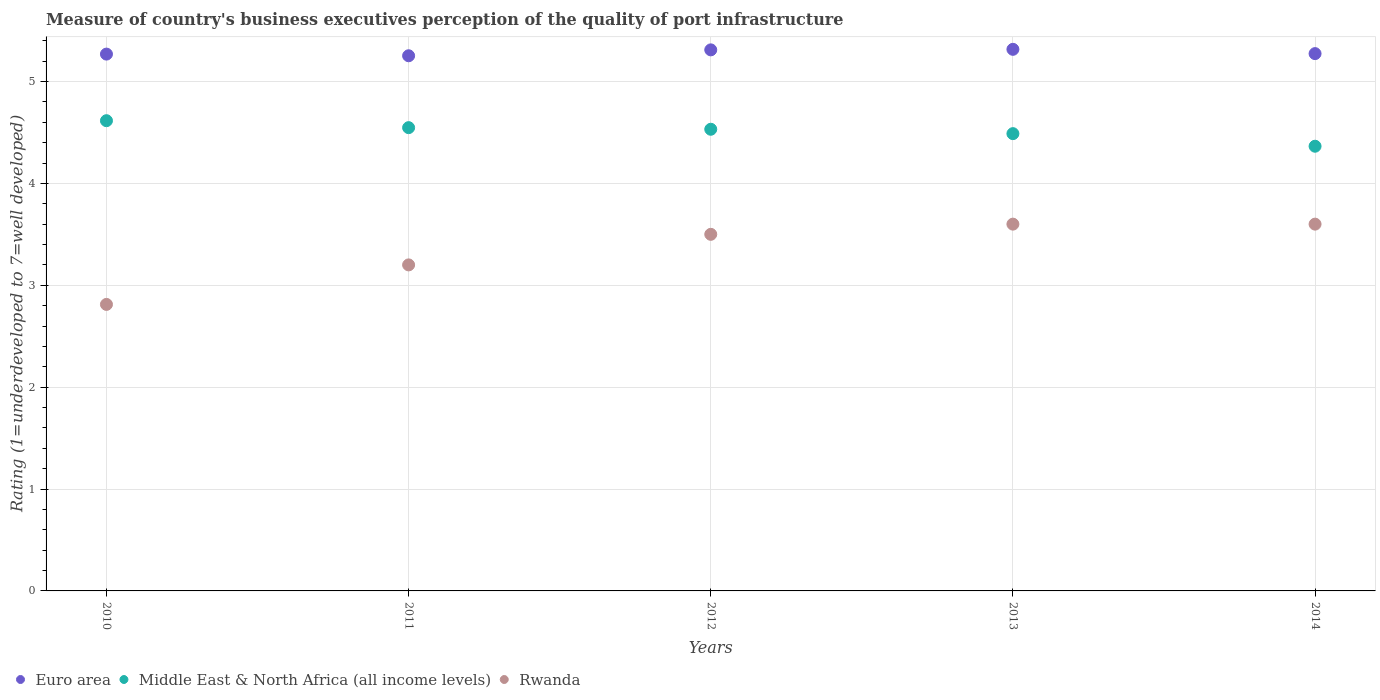How many different coloured dotlines are there?
Your response must be concise. 3. Across all years, what is the minimum ratings of the quality of port infrastructure in Rwanda?
Make the answer very short. 2.81. In which year was the ratings of the quality of port infrastructure in Rwanda minimum?
Your answer should be compact. 2010. What is the total ratings of the quality of port infrastructure in Middle East & North Africa (all income levels) in the graph?
Offer a terse response. 22.55. What is the difference between the ratings of the quality of port infrastructure in Middle East & North Africa (all income levels) in 2011 and that in 2014?
Offer a terse response. 0.18. What is the difference between the ratings of the quality of port infrastructure in Middle East & North Africa (all income levels) in 2010 and the ratings of the quality of port infrastructure in Euro area in 2012?
Ensure brevity in your answer.  -0.7. What is the average ratings of the quality of port infrastructure in Rwanda per year?
Ensure brevity in your answer.  3.34. In the year 2010, what is the difference between the ratings of the quality of port infrastructure in Middle East & North Africa (all income levels) and ratings of the quality of port infrastructure in Rwanda?
Offer a terse response. 1.8. In how many years, is the ratings of the quality of port infrastructure in Euro area greater than 0.4?
Offer a very short reply. 5. Is the ratings of the quality of port infrastructure in Rwanda in 2010 less than that in 2013?
Keep it short and to the point. Yes. What is the difference between the highest and the second highest ratings of the quality of port infrastructure in Middle East & North Africa (all income levels)?
Offer a terse response. 0.07. What is the difference between the highest and the lowest ratings of the quality of port infrastructure in Rwanda?
Provide a short and direct response. 0.79. Is the sum of the ratings of the quality of port infrastructure in Middle East & North Africa (all income levels) in 2010 and 2014 greater than the maximum ratings of the quality of port infrastructure in Rwanda across all years?
Offer a very short reply. Yes. Is it the case that in every year, the sum of the ratings of the quality of port infrastructure in Rwanda and ratings of the quality of port infrastructure in Euro area  is greater than the ratings of the quality of port infrastructure in Middle East & North Africa (all income levels)?
Your answer should be very brief. Yes. Is the ratings of the quality of port infrastructure in Rwanda strictly greater than the ratings of the quality of port infrastructure in Euro area over the years?
Your answer should be very brief. No. Is the ratings of the quality of port infrastructure in Euro area strictly less than the ratings of the quality of port infrastructure in Middle East & North Africa (all income levels) over the years?
Make the answer very short. No. Are the values on the major ticks of Y-axis written in scientific E-notation?
Offer a very short reply. No. Does the graph contain any zero values?
Offer a terse response. No. Does the graph contain grids?
Provide a short and direct response. Yes. How many legend labels are there?
Your answer should be compact. 3. What is the title of the graph?
Give a very brief answer. Measure of country's business executives perception of the quality of port infrastructure. What is the label or title of the X-axis?
Give a very brief answer. Years. What is the label or title of the Y-axis?
Your response must be concise. Rating (1=underdeveloped to 7=well developed). What is the Rating (1=underdeveloped to 7=well developed) of Euro area in 2010?
Offer a terse response. 5.27. What is the Rating (1=underdeveloped to 7=well developed) of Middle East & North Africa (all income levels) in 2010?
Make the answer very short. 4.62. What is the Rating (1=underdeveloped to 7=well developed) of Rwanda in 2010?
Offer a terse response. 2.81. What is the Rating (1=underdeveloped to 7=well developed) of Euro area in 2011?
Your answer should be very brief. 5.25. What is the Rating (1=underdeveloped to 7=well developed) of Middle East & North Africa (all income levels) in 2011?
Provide a short and direct response. 4.55. What is the Rating (1=underdeveloped to 7=well developed) of Euro area in 2012?
Offer a very short reply. 5.31. What is the Rating (1=underdeveloped to 7=well developed) in Middle East & North Africa (all income levels) in 2012?
Your response must be concise. 4.53. What is the Rating (1=underdeveloped to 7=well developed) of Euro area in 2013?
Ensure brevity in your answer.  5.32. What is the Rating (1=underdeveloped to 7=well developed) in Middle East & North Africa (all income levels) in 2013?
Ensure brevity in your answer.  4.49. What is the Rating (1=underdeveloped to 7=well developed) of Euro area in 2014?
Ensure brevity in your answer.  5.27. What is the Rating (1=underdeveloped to 7=well developed) of Middle East & North Africa (all income levels) in 2014?
Offer a terse response. 4.36. What is the Rating (1=underdeveloped to 7=well developed) of Rwanda in 2014?
Make the answer very short. 3.6. Across all years, what is the maximum Rating (1=underdeveloped to 7=well developed) of Euro area?
Give a very brief answer. 5.32. Across all years, what is the maximum Rating (1=underdeveloped to 7=well developed) in Middle East & North Africa (all income levels)?
Keep it short and to the point. 4.62. Across all years, what is the minimum Rating (1=underdeveloped to 7=well developed) of Euro area?
Ensure brevity in your answer.  5.25. Across all years, what is the minimum Rating (1=underdeveloped to 7=well developed) of Middle East & North Africa (all income levels)?
Provide a short and direct response. 4.36. Across all years, what is the minimum Rating (1=underdeveloped to 7=well developed) of Rwanda?
Keep it short and to the point. 2.81. What is the total Rating (1=underdeveloped to 7=well developed) of Euro area in the graph?
Offer a very short reply. 26.42. What is the total Rating (1=underdeveloped to 7=well developed) of Middle East & North Africa (all income levels) in the graph?
Make the answer very short. 22.55. What is the total Rating (1=underdeveloped to 7=well developed) in Rwanda in the graph?
Provide a short and direct response. 16.71. What is the difference between the Rating (1=underdeveloped to 7=well developed) in Euro area in 2010 and that in 2011?
Keep it short and to the point. 0.02. What is the difference between the Rating (1=underdeveloped to 7=well developed) in Middle East & North Africa (all income levels) in 2010 and that in 2011?
Provide a short and direct response. 0.07. What is the difference between the Rating (1=underdeveloped to 7=well developed) in Rwanda in 2010 and that in 2011?
Your answer should be very brief. -0.39. What is the difference between the Rating (1=underdeveloped to 7=well developed) of Euro area in 2010 and that in 2012?
Provide a short and direct response. -0.04. What is the difference between the Rating (1=underdeveloped to 7=well developed) in Middle East & North Africa (all income levels) in 2010 and that in 2012?
Your answer should be compact. 0.08. What is the difference between the Rating (1=underdeveloped to 7=well developed) of Rwanda in 2010 and that in 2012?
Provide a short and direct response. -0.69. What is the difference between the Rating (1=underdeveloped to 7=well developed) in Euro area in 2010 and that in 2013?
Give a very brief answer. -0.05. What is the difference between the Rating (1=underdeveloped to 7=well developed) of Middle East & North Africa (all income levels) in 2010 and that in 2013?
Offer a terse response. 0.13. What is the difference between the Rating (1=underdeveloped to 7=well developed) of Rwanda in 2010 and that in 2013?
Your response must be concise. -0.79. What is the difference between the Rating (1=underdeveloped to 7=well developed) in Euro area in 2010 and that in 2014?
Your response must be concise. -0. What is the difference between the Rating (1=underdeveloped to 7=well developed) of Middle East & North Africa (all income levels) in 2010 and that in 2014?
Provide a short and direct response. 0.25. What is the difference between the Rating (1=underdeveloped to 7=well developed) in Rwanda in 2010 and that in 2014?
Your answer should be very brief. -0.79. What is the difference between the Rating (1=underdeveloped to 7=well developed) of Euro area in 2011 and that in 2012?
Provide a succinct answer. -0.06. What is the difference between the Rating (1=underdeveloped to 7=well developed) in Middle East & North Africa (all income levels) in 2011 and that in 2012?
Make the answer very short. 0.02. What is the difference between the Rating (1=underdeveloped to 7=well developed) of Euro area in 2011 and that in 2013?
Make the answer very short. -0.06. What is the difference between the Rating (1=underdeveloped to 7=well developed) in Middle East & North Africa (all income levels) in 2011 and that in 2013?
Provide a short and direct response. 0.06. What is the difference between the Rating (1=underdeveloped to 7=well developed) in Rwanda in 2011 and that in 2013?
Your answer should be compact. -0.4. What is the difference between the Rating (1=underdeveloped to 7=well developed) of Euro area in 2011 and that in 2014?
Keep it short and to the point. -0.02. What is the difference between the Rating (1=underdeveloped to 7=well developed) in Middle East & North Africa (all income levels) in 2011 and that in 2014?
Offer a terse response. 0.18. What is the difference between the Rating (1=underdeveloped to 7=well developed) in Euro area in 2012 and that in 2013?
Keep it short and to the point. -0.01. What is the difference between the Rating (1=underdeveloped to 7=well developed) of Middle East & North Africa (all income levels) in 2012 and that in 2013?
Make the answer very short. 0.04. What is the difference between the Rating (1=underdeveloped to 7=well developed) of Rwanda in 2012 and that in 2013?
Give a very brief answer. -0.1. What is the difference between the Rating (1=underdeveloped to 7=well developed) in Euro area in 2012 and that in 2014?
Offer a terse response. 0.04. What is the difference between the Rating (1=underdeveloped to 7=well developed) in Middle East & North Africa (all income levels) in 2012 and that in 2014?
Provide a short and direct response. 0.17. What is the difference between the Rating (1=underdeveloped to 7=well developed) in Euro area in 2013 and that in 2014?
Offer a very short reply. 0.04. What is the difference between the Rating (1=underdeveloped to 7=well developed) of Middle East & North Africa (all income levels) in 2013 and that in 2014?
Provide a short and direct response. 0.12. What is the difference between the Rating (1=underdeveloped to 7=well developed) in Euro area in 2010 and the Rating (1=underdeveloped to 7=well developed) in Middle East & North Africa (all income levels) in 2011?
Ensure brevity in your answer.  0.72. What is the difference between the Rating (1=underdeveloped to 7=well developed) of Euro area in 2010 and the Rating (1=underdeveloped to 7=well developed) of Rwanda in 2011?
Keep it short and to the point. 2.07. What is the difference between the Rating (1=underdeveloped to 7=well developed) in Middle East & North Africa (all income levels) in 2010 and the Rating (1=underdeveloped to 7=well developed) in Rwanda in 2011?
Provide a short and direct response. 1.42. What is the difference between the Rating (1=underdeveloped to 7=well developed) in Euro area in 2010 and the Rating (1=underdeveloped to 7=well developed) in Middle East & North Africa (all income levels) in 2012?
Provide a succinct answer. 0.74. What is the difference between the Rating (1=underdeveloped to 7=well developed) of Euro area in 2010 and the Rating (1=underdeveloped to 7=well developed) of Rwanda in 2012?
Your answer should be very brief. 1.77. What is the difference between the Rating (1=underdeveloped to 7=well developed) of Middle East & North Africa (all income levels) in 2010 and the Rating (1=underdeveloped to 7=well developed) of Rwanda in 2012?
Offer a terse response. 1.12. What is the difference between the Rating (1=underdeveloped to 7=well developed) in Euro area in 2010 and the Rating (1=underdeveloped to 7=well developed) in Middle East & North Africa (all income levels) in 2013?
Make the answer very short. 0.78. What is the difference between the Rating (1=underdeveloped to 7=well developed) of Euro area in 2010 and the Rating (1=underdeveloped to 7=well developed) of Rwanda in 2013?
Offer a terse response. 1.67. What is the difference between the Rating (1=underdeveloped to 7=well developed) in Middle East & North Africa (all income levels) in 2010 and the Rating (1=underdeveloped to 7=well developed) in Rwanda in 2013?
Give a very brief answer. 1.02. What is the difference between the Rating (1=underdeveloped to 7=well developed) in Euro area in 2010 and the Rating (1=underdeveloped to 7=well developed) in Middle East & North Africa (all income levels) in 2014?
Provide a short and direct response. 0.9. What is the difference between the Rating (1=underdeveloped to 7=well developed) of Euro area in 2010 and the Rating (1=underdeveloped to 7=well developed) of Rwanda in 2014?
Give a very brief answer. 1.67. What is the difference between the Rating (1=underdeveloped to 7=well developed) of Middle East & North Africa (all income levels) in 2010 and the Rating (1=underdeveloped to 7=well developed) of Rwanda in 2014?
Provide a short and direct response. 1.02. What is the difference between the Rating (1=underdeveloped to 7=well developed) of Euro area in 2011 and the Rating (1=underdeveloped to 7=well developed) of Middle East & North Africa (all income levels) in 2012?
Offer a very short reply. 0.72. What is the difference between the Rating (1=underdeveloped to 7=well developed) of Euro area in 2011 and the Rating (1=underdeveloped to 7=well developed) of Rwanda in 2012?
Offer a very short reply. 1.75. What is the difference between the Rating (1=underdeveloped to 7=well developed) in Middle East & North Africa (all income levels) in 2011 and the Rating (1=underdeveloped to 7=well developed) in Rwanda in 2012?
Give a very brief answer. 1.05. What is the difference between the Rating (1=underdeveloped to 7=well developed) in Euro area in 2011 and the Rating (1=underdeveloped to 7=well developed) in Middle East & North Africa (all income levels) in 2013?
Ensure brevity in your answer.  0.76. What is the difference between the Rating (1=underdeveloped to 7=well developed) of Euro area in 2011 and the Rating (1=underdeveloped to 7=well developed) of Rwanda in 2013?
Your answer should be very brief. 1.65. What is the difference between the Rating (1=underdeveloped to 7=well developed) in Middle East & North Africa (all income levels) in 2011 and the Rating (1=underdeveloped to 7=well developed) in Rwanda in 2013?
Offer a terse response. 0.95. What is the difference between the Rating (1=underdeveloped to 7=well developed) in Euro area in 2011 and the Rating (1=underdeveloped to 7=well developed) in Middle East & North Africa (all income levels) in 2014?
Keep it short and to the point. 0.89. What is the difference between the Rating (1=underdeveloped to 7=well developed) of Euro area in 2011 and the Rating (1=underdeveloped to 7=well developed) of Rwanda in 2014?
Offer a very short reply. 1.65. What is the difference between the Rating (1=underdeveloped to 7=well developed) of Middle East & North Africa (all income levels) in 2011 and the Rating (1=underdeveloped to 7=well developed) of Rwanda in 2014?
Provide a succinct answer. 0.95. What is the difference between the Rating (1=underdeveloped to 7=well developed) in Euro area in 2012 and the Rating (1=underdeveloped to 7=well developed) in Middle East & North Africa (all income levels) in 2013?
Provide a succinct answer. 0.82. What is the difference between the Rating (1=underdeveloped to 7=well developed) of Euro area in 2012 and the Rating (1=underdeveloped to 7=well developed) of Rwanda in 2013?
Give a very brief answer. 1.71. What is the difference between the Rating (1=underdeveloped to 7=well developed) of Middle East & North Africa (all income levels) in 2012 and the Rating (1=underdeveloped to 7=well developed) of Rwanda in 2013?
Provide a short and direct response. 0.93. What is the difference between the Rating (1=underdeveloped to 7=well developed) of Euro area in 2012 and the Rating (1=underdeveloped to 7=well developed) of Middle East & North Africa (all income levels) in 2014?
Keep it short and to the point. 0.95. What is the difference between the Rating (1=underdeveloped to 7=well developed) of Euro area in 2012 and the Rating (1=underdeveloped to 7=well developed) of Rwanda in 2014?
Offer a terse response. 1.71. What is the difference between the Rating (1=underdeveloped to 7=well developed) of Middle East & North Africa (all income levels) in 2012 and the Rating (1=underdeveloped to 7=well developed) of Rwanda in 2014?
Provide a short and direct response. 0.93. What is the difference between the Rating (1=underdeveloped to 7=well developed) of Euro area in 2013 and the Rating (1=underdeveloped to 7=well developed) of Middle East & North Africa (all income levels) in 2014?
Provide a succinct answer. 0.95. What is the difference between the Rating (1=underdeveloped to 7=well developed) in Euro area in 2013 and the Rating (1=underdeveloped to 7=well developed) in Rwanda in 2014?
Ensure brevity in your answer.  1.72. What is the difference between the Rating (1=underdeveloped to 7=well developed) in Middle East & North Africa (all income levels) in 2013 and the Rating (1=underdeveloped to 7=well developed) in Rwanda in 2014?
Keep it short and to the point. 0.89. What is the average Rating (1=underdeveloped to 7=well developed) of Euro area per year?
Offer a terse response. 5.28. What is the average Rating (1=underdeveloped to 7=well developed) of Middle East & North Africa (all income levels) per year?
Your answer should be compact. 4.51. What is the average Rating (1=underdeveloped to 7=well developed) of Rwanda per year?
Ensure brevity in your answer.  3.34. In the year 2010, what is the difference between the Rating (1=underdeveloped to 7=well developed) of Euro area and Rating (1=underdeveloped to 7=well developed) of Middle East & North Africa (all income levels)?
Provide a succinct answer. 0.65. In the year 2010, what is the difference between the Rating (1=underdeveloped to 7=well developed) of Euro area and Rating (1=underdeveloped to 7=well developed) of Rwanda?
Offer a very short reply. 2.46. In the year 2010, what is the difference between the Rating (1=underdeveloped to 7=well developed) of Middle East & North Africa (all income levels) and Rating (1=underdeveloped to 7=well developed) of Rwanda?
Give a very brief answer. 1.8. In the year 2011, what is the difference between the Rating (1=underdeveloped to 7=well developed) of Euro area and Rating (1=underdeveloped to 7=well developed) of Middle East & North Africa (all income levels)?
Provide a short and direct response. 0.71. In the year 2011, what is the difference between the Rating (1=underdeveloped to 7=well developed) in Euro area and Rating (1=underdeveloped to 7=well developed) in Rwanda?
Ensure brevity in your answer.  2.05. In the year 2011, what is the difference between the Rating (1=underdeveloped to 7=well developed) in Middle East & North Africa (all income levels) and Rating (1=underdeveloped to 7=well developed) in Rwanda?
Make the answer very short. 1.35. In the year 2012, what is the difference between the Rating (1=underdeveloped to 7=well developed) of Euro area and Rating (1=underdeveloped to 7=well developed) of Middle East & North Africa (all income levels)?
Your answer should be very brief. 0.78. In the year 2012, what is the difference between the Rating (1=underdeveloped to 7=well developed) in Euro area and Rating (1=underdeveloped to 7=well developed) in Rwanda?
Your response must be concise. 1.81. In the year 2012, what is the difference between the Rating (1=underdeveloped to 7=well developed) in Middle East & North Africa (all income levels) and Rating (1=underdeveloped to 7=well developed) in Rwanda?
Make the answer very short. 1.03. In the year 2013, what is the difference between the Rating (1=underdeveloped to 7=well developed) of Euro area and Rating (1=underdeveloped to 7=well developed) of Middle East & North Africa (all income levels)?
Provide a short and direct response. 0.83. In the year 2013, what is the difference between the Rating (1=underdeveloped to 7=well developed) in Euro area and Rating (1=underdeveloped to 7=well developed) in Rwanda?
Give a very brief answer. 1.72. In the year 2013, what is the difference between the Rating (1=underdeveloped to 7=well developed) of Middle East & North Africa (all income levels) and Rating (1=underdeveloped to 7=well developed) of Rwanda?
Your response must be concise. 0.89. In the year 2014, what is the difference between the Rating (1=underdeveloped to 7=well developed) of Euro area and Rating (1=underdeveloped to 7=well developed) of Middle East & North Africa (all income levels)?
Offer a terse response. 0.91. In the year 2014, what is the difference between the Rating (1=underdeveloped to 7=well developed) in Euro area and Rating (1=underdeveloped to 7=well developed) in Rwanda?
Make the answer very short. 1.67. In the year 2014, what is the difference between the Rating (1=underdeveloped to 7=well developed) of Middle East & North Africa (all income levels) and Rating (1=underdeveloped to 7=well developed) of Rwanda?
Make the answer very short. 0.76. What is the ratio of the Rating (1=underdeveloped to 7=well developed) of Rwanda in 2010 to that in 2011?
Make the answer very short. 0.88. What is the ratio of the Rating (1=underdeveloped to 7=well developed) in Middle East & North Africa (all income levels) in 2010 to that in 2012?
Make the answer very short. 1.02. What is the ratio of the Rating (1=underdeveloped to 7=well developed) in Rwanda in 2010 to that in 2012?
Make the answer very short. 0.8. What is the ratio of the Rating (1=underdeveloped to 7=well developed) in Euro area in 2010 to that in 2013?
Make the answer very short. 0.99. What is the ratio of the Rating (1=underdeveloped to 7=well developed) in Middle East & North Africa (all income levels) in 2010 to that in 2013?
Make the answer very short. 1.03. What is the ratio of the Rating (1=underdeveloped to 7=well developed) of Rwanda in 2010 to that in 2013?
Your answer should be very brief. 0.78. What is the ratio of the Rating (1=underdeveloped to 7=well developed) in Middle East & North Africa (all income levels) in 2010 to that in 2014?
Ensure brevity in your answer.  1.06. What is the ratio of the Rating (1=underdeveloped to 7=well developed) of Rwanda in 2010 to that in 2014?
Offer a terse response. 0.78. What is the ratio of the Rating (1=underdeveloped to 7=well developed) in Euro area in 2011 to that in 2012?
Provide a succinct answer. 0.99. What is the ratio of the Rating (1=underdeveloped to 7=well developed) of Rwanda in 2011 to that in 2012?
Provide a succinct answer. 0.91. What is the ratio of the Rating (1=underdeveloped to 7=well developed) of Middle East & North Africa (all income levels) in 2011 to that in 2013?
Provide a succinct answer. 1.01. What is the ratio of the Rating (1=underdeveloped to 7=well developed) in Euro area in 2011 to that in 2014?
Offer a terse response. 1. What is the ratio of the Rating (1=underdeveloped to 7=well developed) in Middle East & North Africa (all income levels) in 2011 to that in 2014?
Your answer should be compact. 1.04. What is the ratio of the Rating (1=underdeveloped to 7=well developed) of Middle East & North Africa (all income levels) in 2012 to that in 2013?
Offer a very short reply. 1.01. What is the ratio of the Rating (1=underdeveloped to 7=well developed) in Rwanda in 2012 to that in 2013?
Keep it short and to the point. 0.97. What is the ratio of the Rating (1=underdeveloped to 7=well developed) of Euro area in 2012 to that in 2014?
Your answer should be very brief. 1.01. What is the ratio of the Rating (1=underdeveloped to 7=well developed) in Middle East & North Africa (all income levels) in 2012 to that in 2014?
Your answer should be compact. 1.04. What is the ratio of the Rating (1=underdeveloped to 7=well developed) in Rwanda in 2012 to that in 2014?
Your answer should be compact. 0.97. What is the ratio of the Rating (1=underdeveloped to 7=well developed) of Middle East & North Africa (all income levels) in 2013 to that in 2014?
Ensure brevity in your answer.  1.03. What is the difference between the highest and the second highest Rating (1=underdeveloped to 7=well developed) of Euro area?
Give a very brief answer. 0.01. What is the difference between the highest and the second highest Rating (1=underdeveloped to 7=well developed) in Middle East & North Africa (all income levels)?
Ensure brevity in your answer.  0.07. What is the difference between the highest and the second highest Rating (1=underdeveloped to 7=well developed) in Rwanda?
Provide a short and direct response. 0. What is the difference between the highest and the lowest Rating (1=underdeveloped to 7=well developed) in Euro area?
Your answer should be compact. 0.06. What is the difference between the highest and the lowest Rating (1=underdeveloped to 7=well developed) of Middle East & North Africa (all income levels)?
Your answer should be very brief. 0.25. What is the difference between the highest and the lowest Rating (1=underdeveloped to 7=well developed) of Rwanda?
Provide a succinct answer. 0.79. 